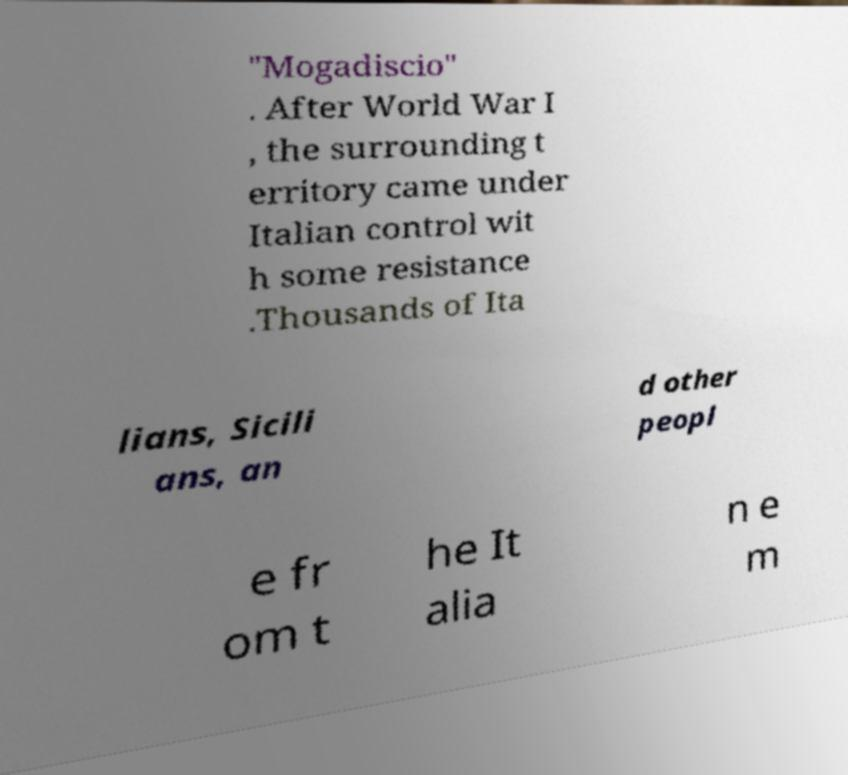For documentation purposes, I need the text within this image transcribed. Could you provide that? "Mogadiscio" . After World War I , the surrounding t erritory came under Italian control wit h some resistance .Thousands of Ita lians, Sicili ans, an d other peopl e fr om t he It alia n e m 